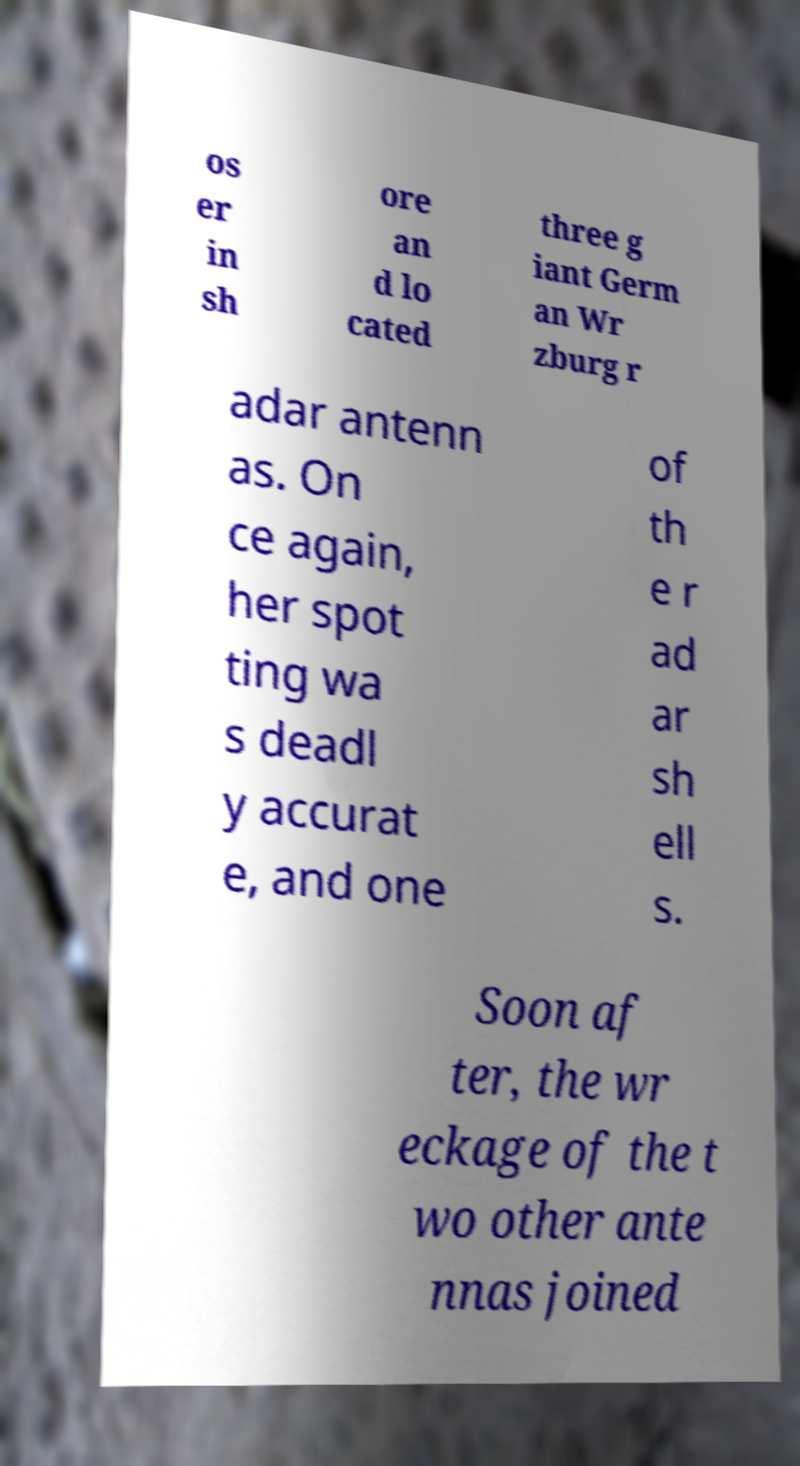Could you assist in decoding the text presented in this image and type it out clearly? os er in sh ore an d lo cated three g iant Germ an Wr zburg r adar antenn as. On ce again, her spot ting wa s deadl y accurat e, and one of th e r ad ar sh ell s. Soon af ter, the wr eckage of the t wo other ante nnas joined 